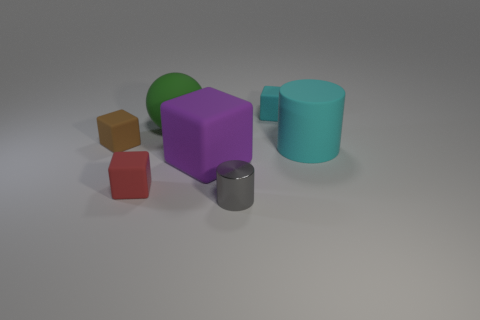Is there another small gray object that has the same shape as the gray object?
Ensure brevity in your answer.  No. How many other things are the same color as the large rubber cylinder?
Keep it short and to the point. 1. What color is the cylinder left of the small matte block right of the large matte sphere that is on the left side of the tiny gray cylinder?
Keep it short and to the point. Gray. Are there the same number of small gray metallic cylinders that are behind the large green matte sphere and brown matte cylinders?
Provide a short and direct response. Yes. There is a cube behind the brown matte object; does it have the same size as the big cyan cylinder?
Provide a short and direct response. No. How many purple rubber cubes are there?
Ensure brevity in your answer.  1. What number of blocks are in front of the large green object and right of the small brown object?
Provide a succinct answer. 2. Are there any purple things that have the same material as the cyan cube?
Your answer should be compact. Yes. What is the object that is right of the cyan rubber object that is behind the rubber sphere made of?
Your answer should be very brief. Rubber. Is the number of green rubber spheres in front of the ball the same as the number of purple things right of the big rubber cylinder?
Offer a terse response. Yes. 